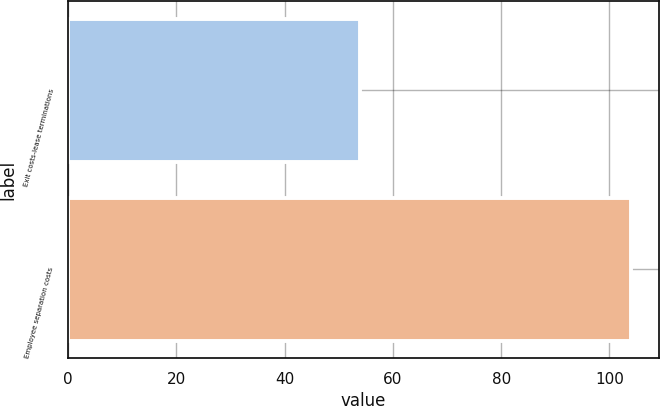Convert chart. <chart><loc_0><loc_0><loc_500><loc_500><bar_chart><fcel>Exit costs-lease terminations<fcel>Employee separation costs<nl><fcel>54<fcel>104<nl></chart> 